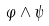Convert formula to latex. <formula><loc_0><loc_0><loc_500><loc_500>\varphi \wedge \psi</formula> 